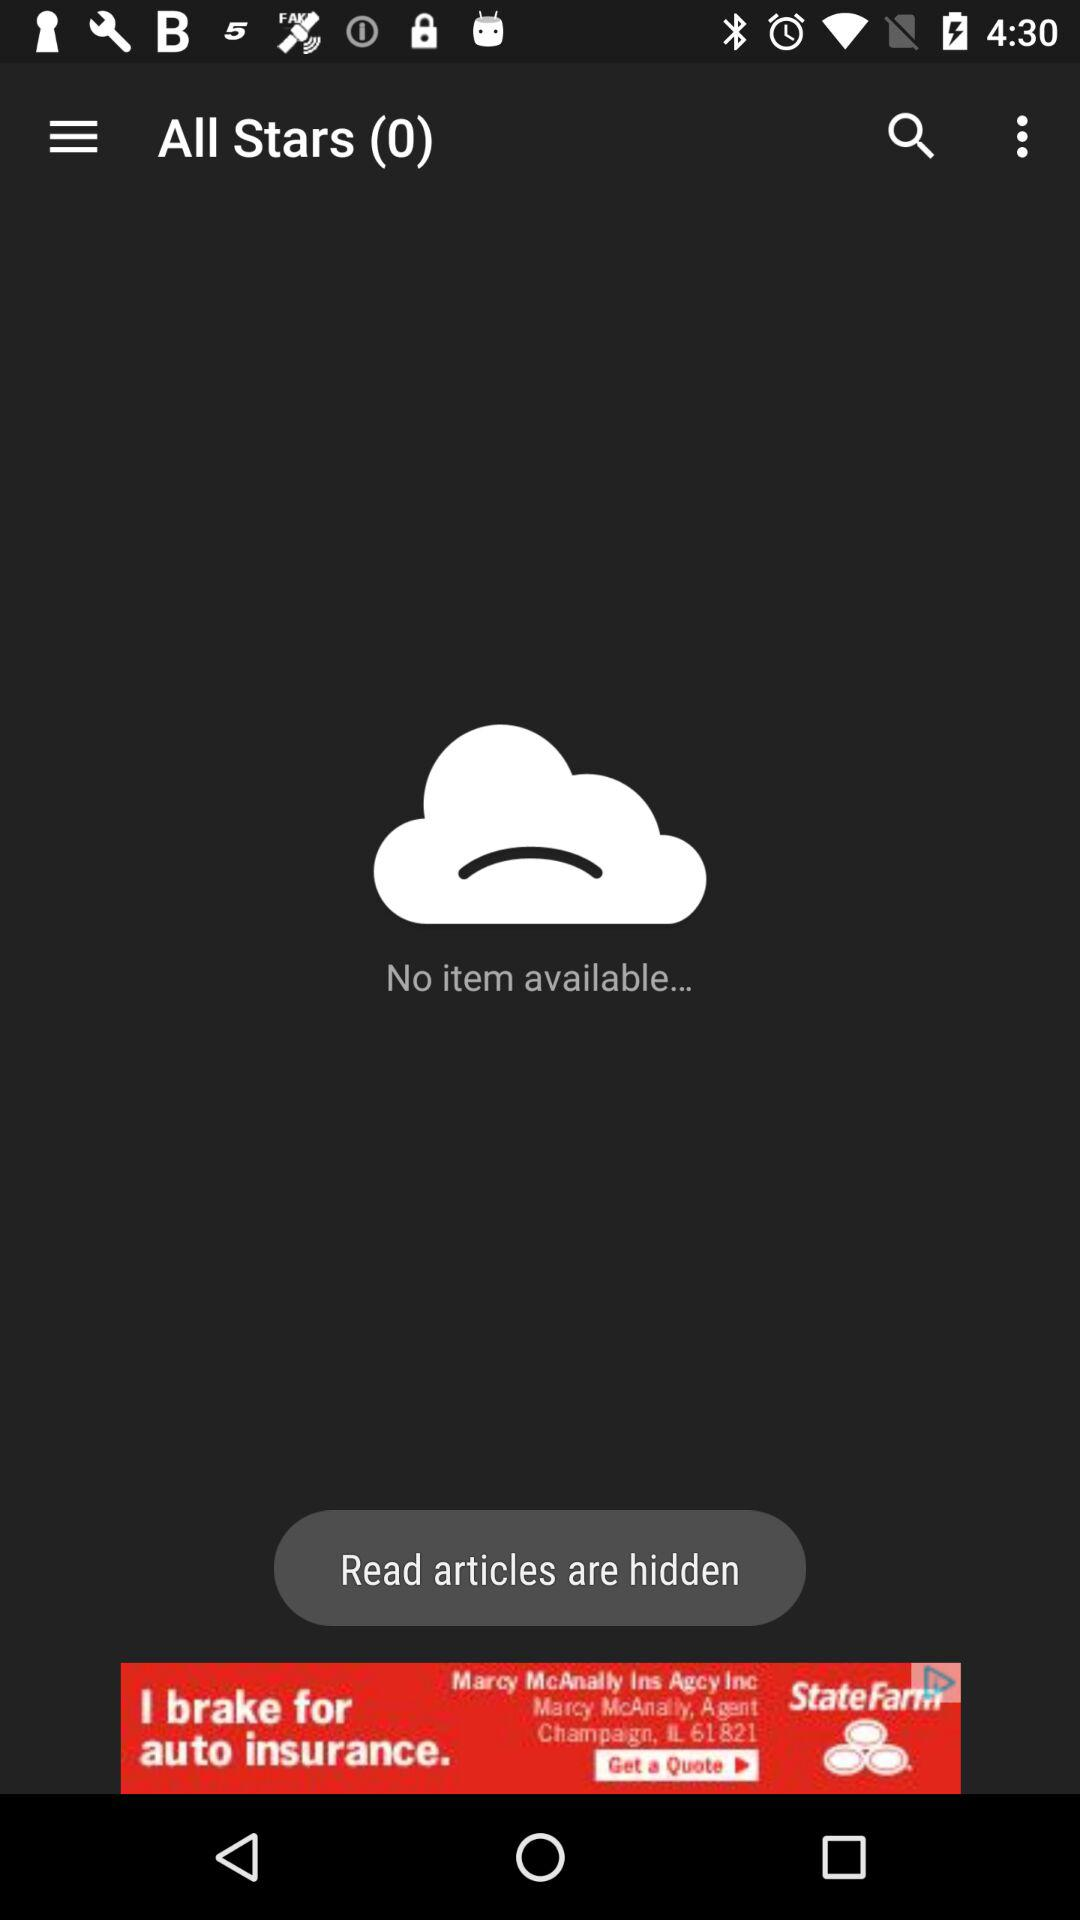Is there any item available? There is no item available. 